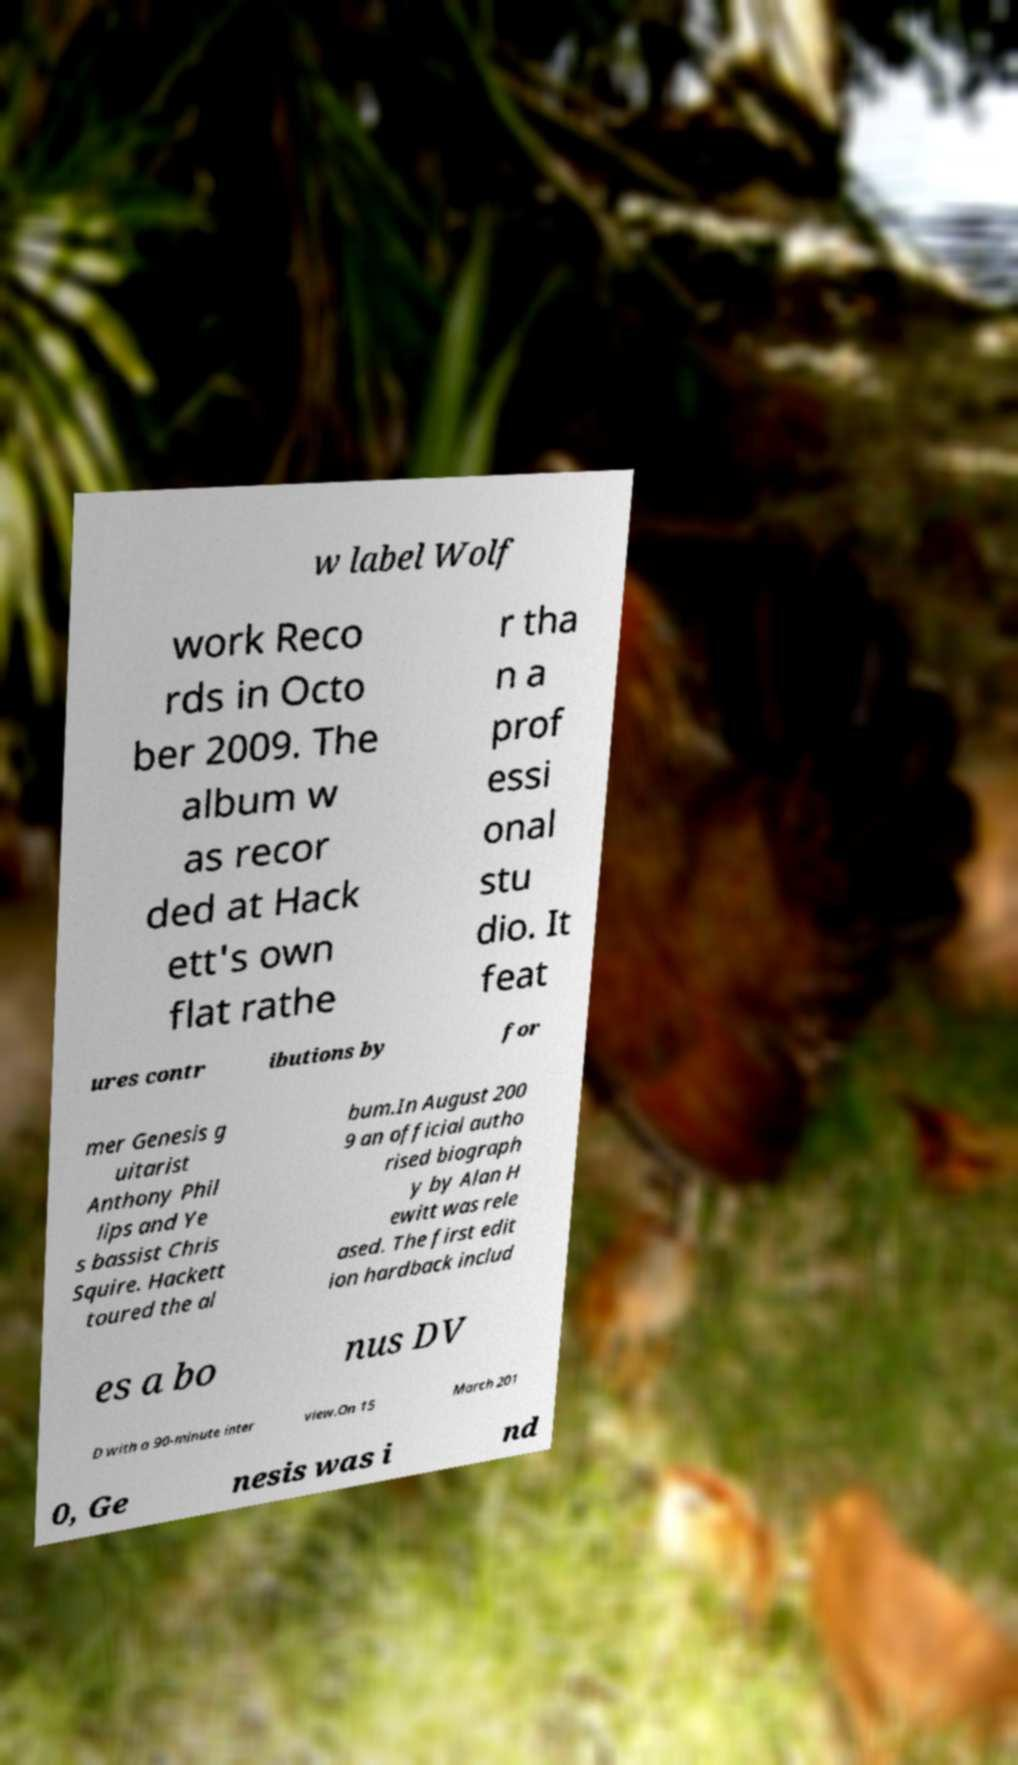Can you accurately transcribe the text from the provided image for me? w label Wolf work Reco rds in Octo ber 2009. The album w as recor ded at Hack ett's own flat rathe r tha n a prof essi onal stu dio. It feat ures contr ibutions by for mer Genesis g uitarist Anthony Phil lips and Ye s bassist Chris Squire. Hackett toured the al bum.In August 200 9 an official autho rised biograph y by Alan H ewitt was rele ased. The first edit ion hardback includ es a bo nus DV D with a 90-minute inter view.On 15 March 201 0, Ge nesis was i nd 